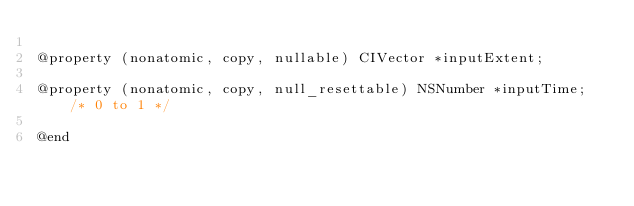Convert code to text. <code><loc_0><loc_0><loc_500><loc_500><_C_>
@property (nonatomic, copy, nullable) CIVector *inputExtent;

@property (nonatomic, copy, null_resettable) NSNumber *inputTime; /* 0 to 1 */

@end
</code> 